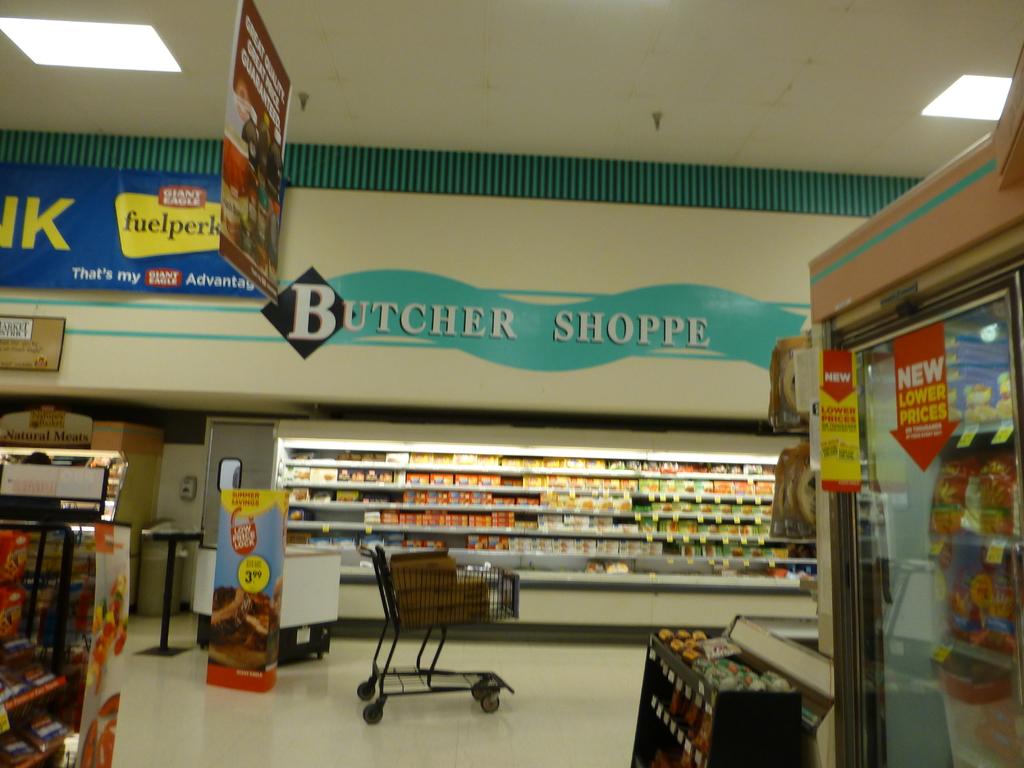Are lower prices new?
Your answer should be very brief. Yes. 